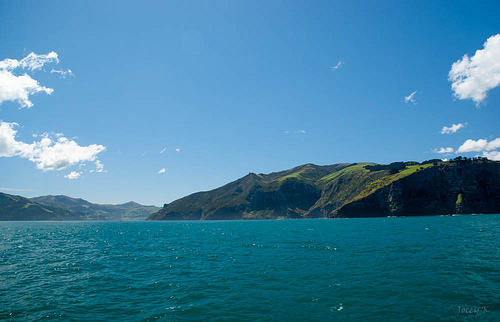<image>
Is the sky to the left of the mountain? No. The sky is not to the left of the mountain. From this viewpoint, they have a different horizontal relationship. Where is the water in relation to the mountain? Is it under the mountain? Yes. The water is positioned underneath the mountain, with the mountain above it in the vertical space. 